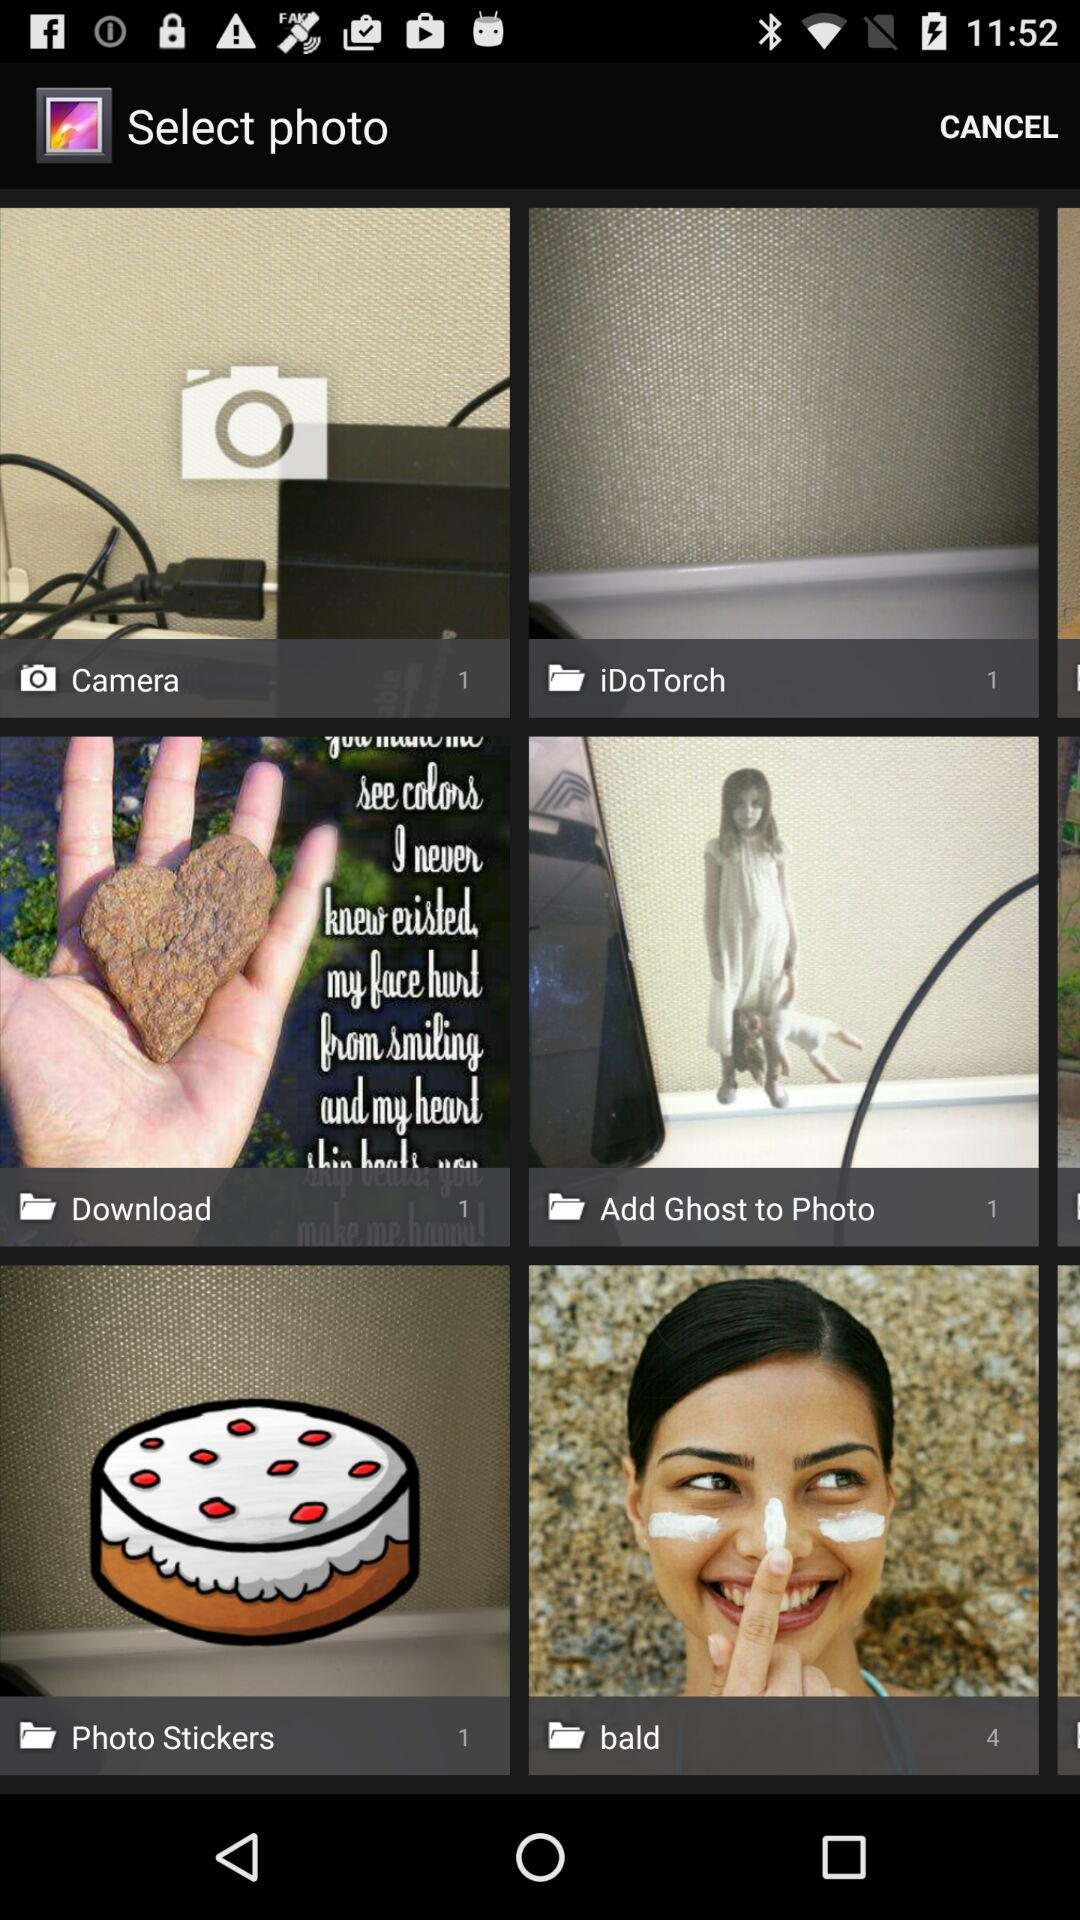How many pictures are in the "Camera" folder? There is 1 picture in the "Camera" folder. 